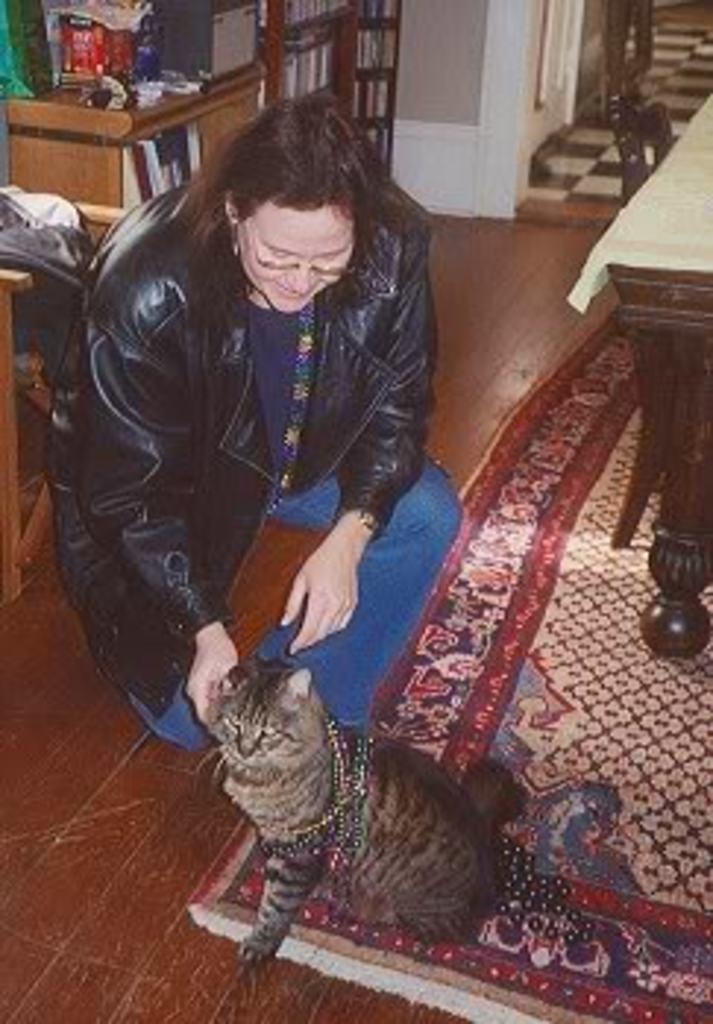Please provide a concise description of this image. In this image I can see a person is playing with a cat. On the right side of the image there is a table covered with a white cloth. On the top of the image there is a rack. 